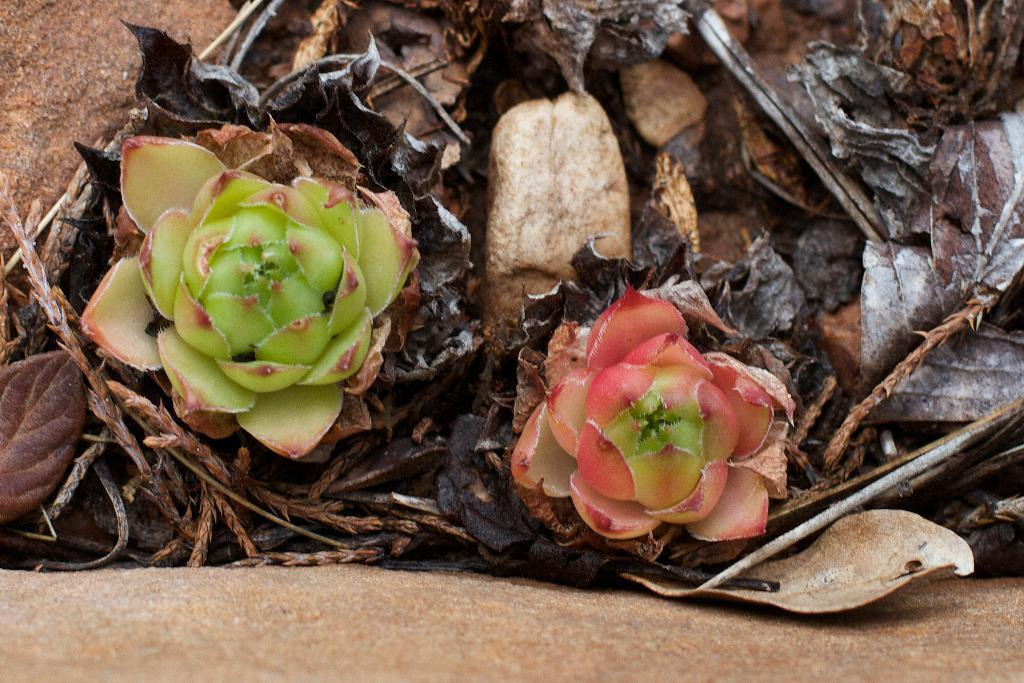What type of plant life can be seen in the image? There are flowers and dried leaves in the image. Can you describe the condition of the leaves in the image? The leaves in the image are dried. What color is the rake used to gather the leaves in the image? There is no rake present in the image, so it is not possible to determine its color. 